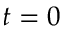<formula> <loc_0><loc_0><loc_500><loc_500>t = 0</formula> 